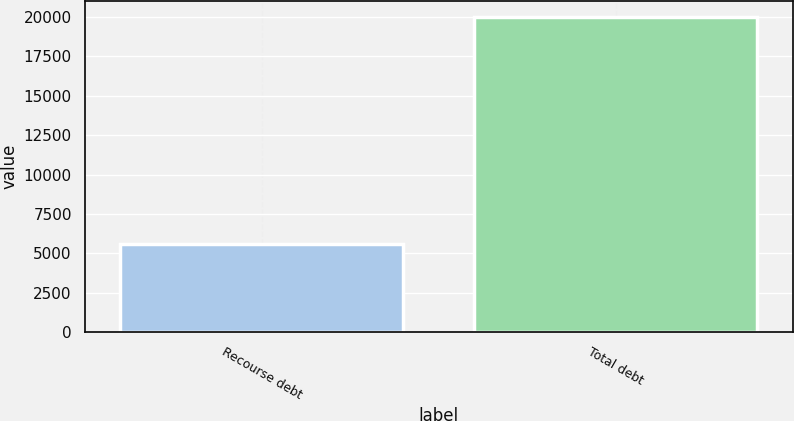<chart> <loc_0><loc_0><loc_500><loc_500><bar_chart><fcel>Recourse debt<fcel>Total debt<nl><fcel>5603<fcel>20008<nl></chart> 